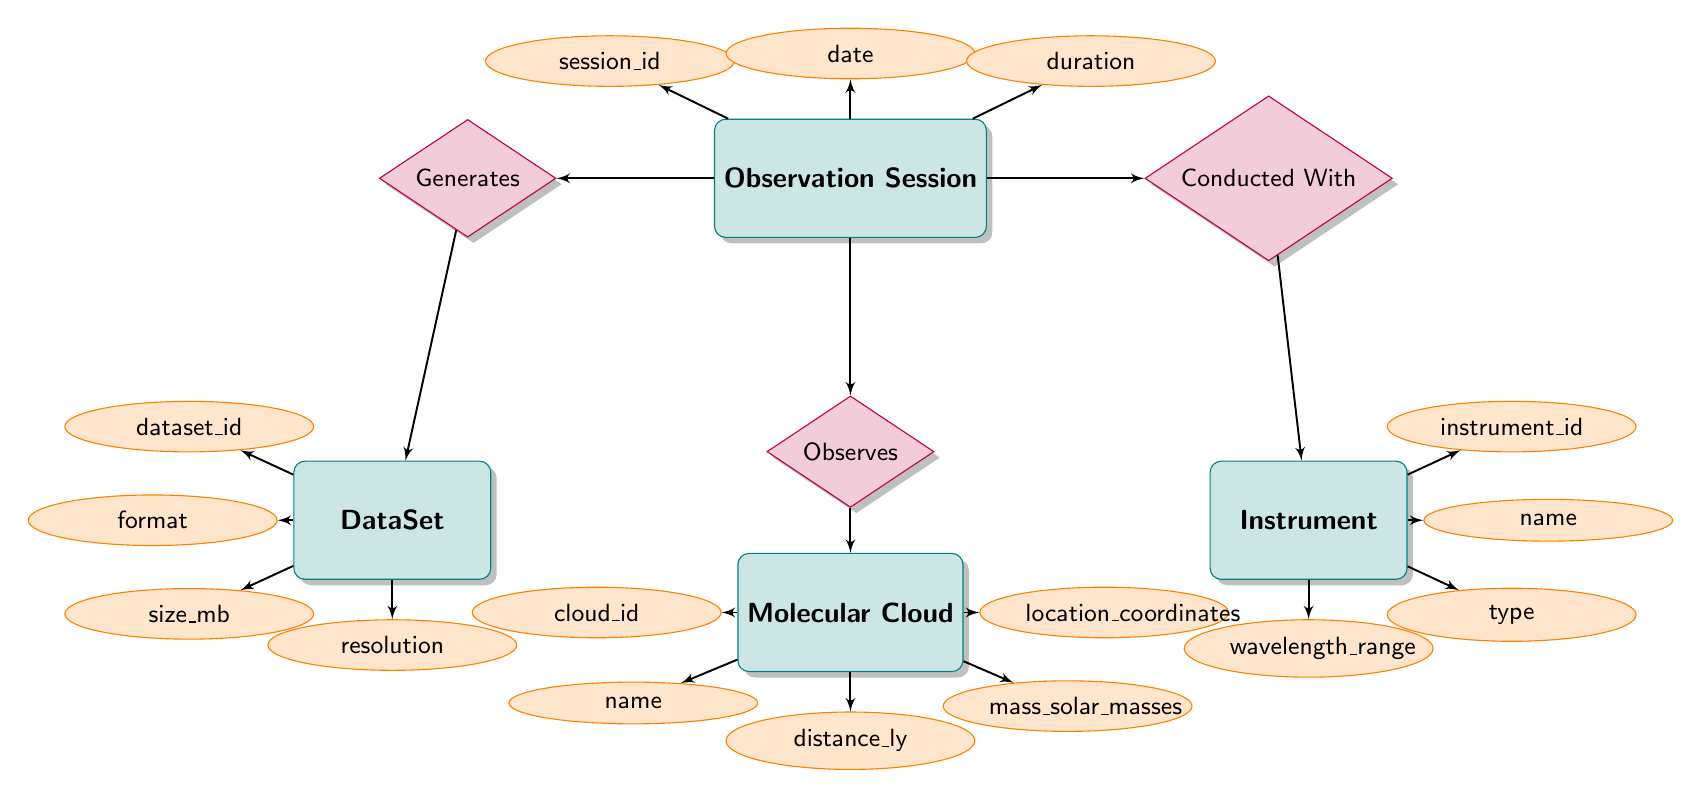What entities are represented in the diagram? The entities represented in the diagram are Observation Session, Instrument, DataSet, and Molecular Cloud. By identifying the rectangles in the diagram, we can list the entities that are involved in the observer data management process.
Answer: Observation Session, Instrument, DataSet, Molecular Cloud How many attributes does the Molecular Cloud entity have? The Molecular Cloud entity has five attributes: cloud_id, name, distance_ly, mass_solar_masses, and location_coordinates. Counting these attributes will give us the total number.
Answer: 5 What is the relationship between Observation Session and Instrument? The relationship between Observation Session and Instrument is called Conducted With. Looking at the diamond connecting these two entities indicates the specific connection they share in the context of the diagram.
Answer: Conducted With Which attribute is associated with the relationship Generates between Observation Session and DataSet? The attributes associated with the relationship Generates are quality and notes. These attributes define specific information that describes the nature of the data generated during the observation session.
Answer: quality, notes How many edges are depicted in the diagram? There are six edges depicted in the diagram, as each relationship connecting entities creates an edge, along with additional edges leading to the attributes of each entity. Counting these connections yields the total.
Answer: 6 What data does the Observes relationship convey? The Observes relationship conveys the attributes intensity and temperature, which describe the observations made during a session regarding the molecular cloud. This relationship indicates what specific data can be extracted or focused on.
Answer: intensity, temperature Which entity generates a DataSet? The entity that generates a DataSet is the Observation Session. By following the relationship Generatess in the diagram, it is clear that the data creation is a direct output of an observation session.
Answer: Observation Session How many different types of Instruments are shown in the diagram? The Instrument entity can represent various types through its attribute "type," but the diagram does not specify a number of instruments. However, the relationship implies that there can be multiple instances of the Instrument entity associated with the Observation Session.
Answer: Multiple types What can be inferred about the relationship between Observation Session and Molecular Cloud? It can be inferred that the relationship between Observation Session and Molecular Cloud is that the session actively observes the molecular clouds, as indicated by the Observes relationship. This implies an interaction where data is collected.
Answer: Observes 